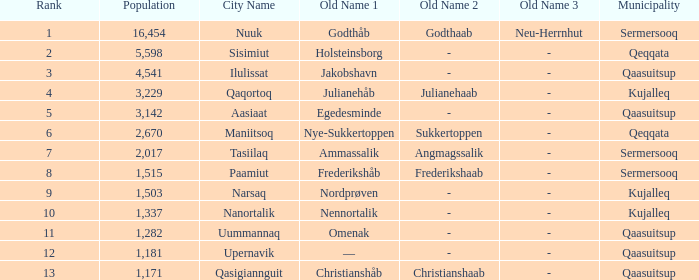Who has a former name of nordprøven? Narsaq. 